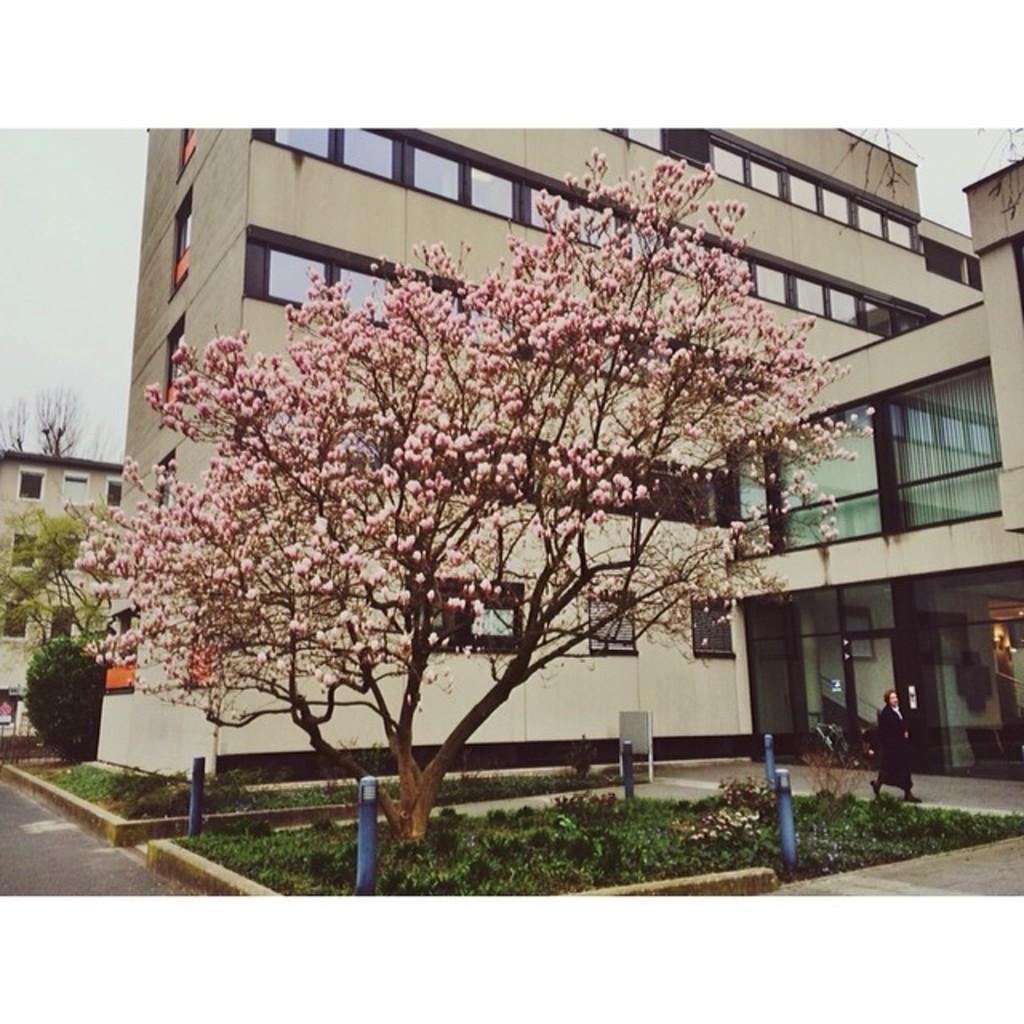Please provide a concise description of this image. In this image I can see a tree and a pink color flower. Back Side I can see a building and glass window. I can see a person walking and wearing black dress. I can see poles and a board. The sky is in white color. 